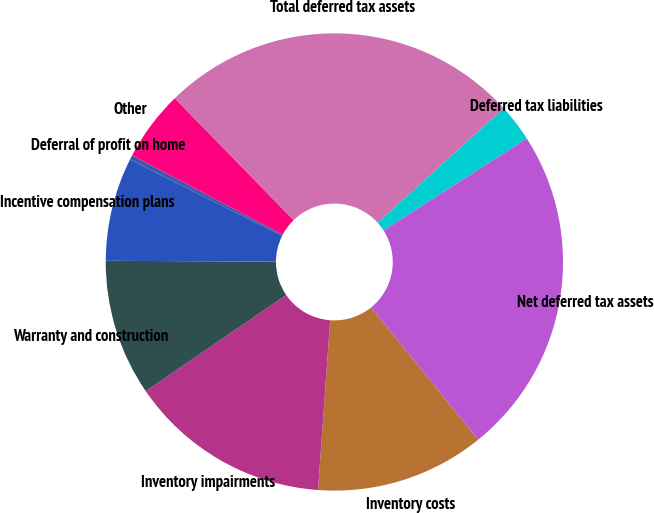<chart> <loc_0><loc_0><loc_500><loc_500><pie_chart><fcel>Inventory costs<fcel>Inventory impairments<fcel>Warranty and construction<fcel>Incentive compensation plans<fcel>Deferral of profit on home<fcel>Other<fcel>Total deferred tax assets<fcel>Deferred tax liabilities<fcel>Net deferred tax assets<nl><fcel>11.97%<fcel>14.3%<fcel>9.64%<fcel>7.31%<fcel>0.33%<fcel>4.98%<fcel>25.57%<fcel>2.65%<fcel>23.24%<nl></chart> 